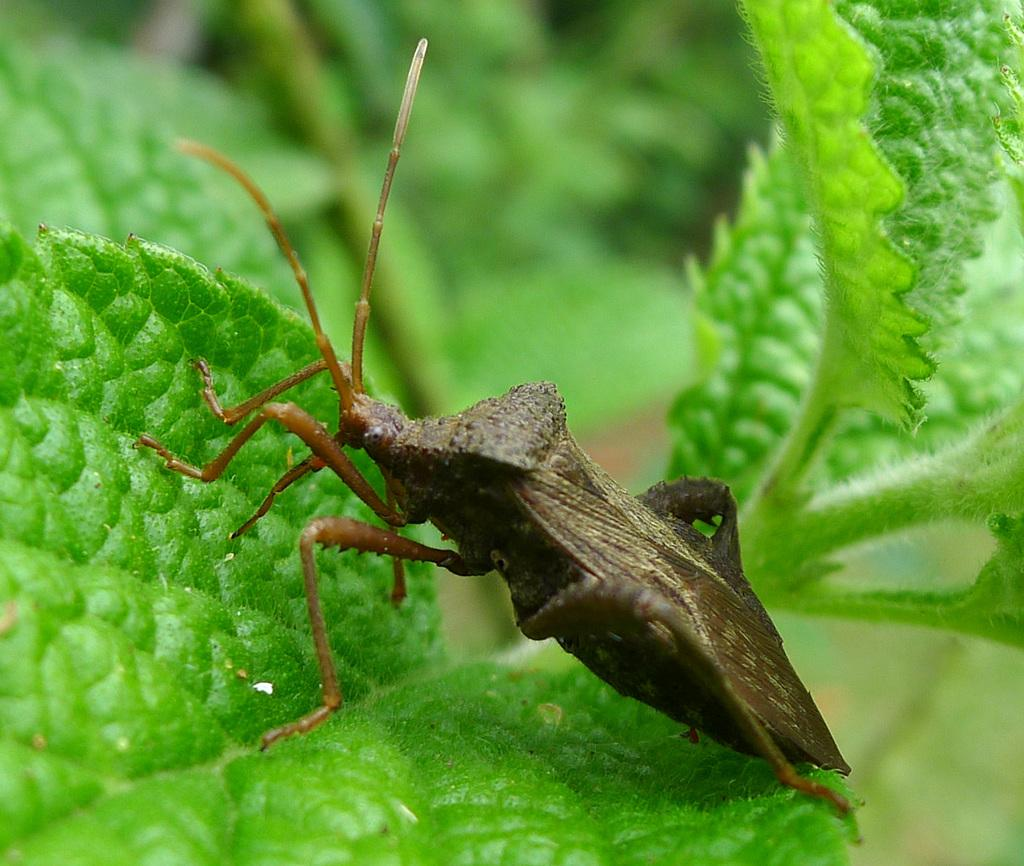What type of creature can be seen in the image? There is an insect in the image. Where is the insect located in the image? The insect is on the leaves. What type of blade is being used to cut the pickle in the image? There is no blade or pickle present in the image; it only features an insect on the leaves. What belief system is depicted in the image? There is no depiction of a belief system in the image; it only features an insect on the leaves. 